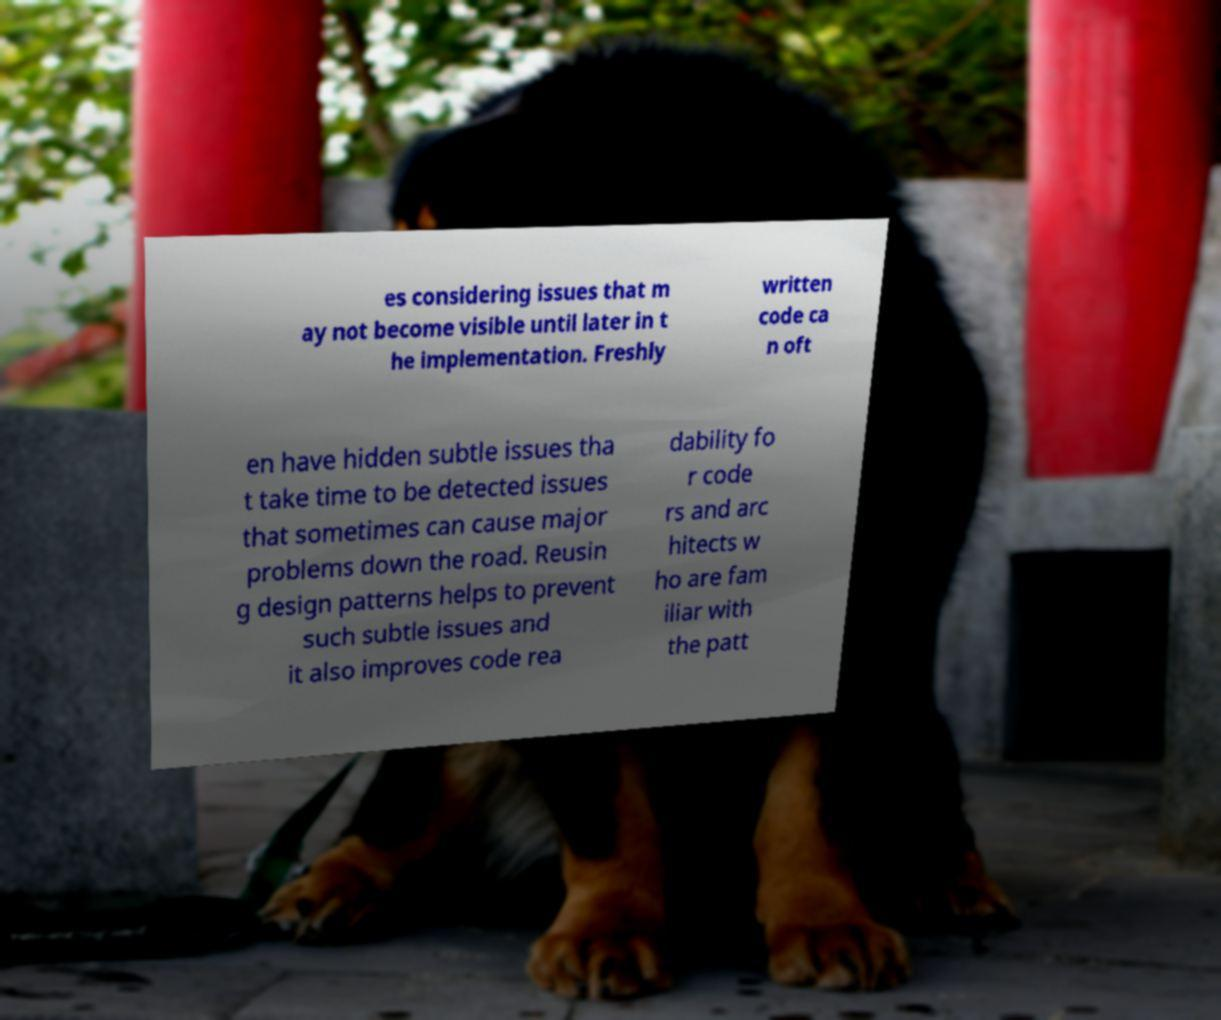Please read and relay the text visible in this image. What does it say? es considering issues that m ay not become visible until later in t he implementation. Freshly written code ca n oft en have hidden subtle issues tha t take time to be detected issues that sometimes can cause major problems down the road. Reusin g design patterns helps to prevent such subtle issues and it also improves code rea dability fo r code rs and arc hitects w ho are fam iliar with the patt 